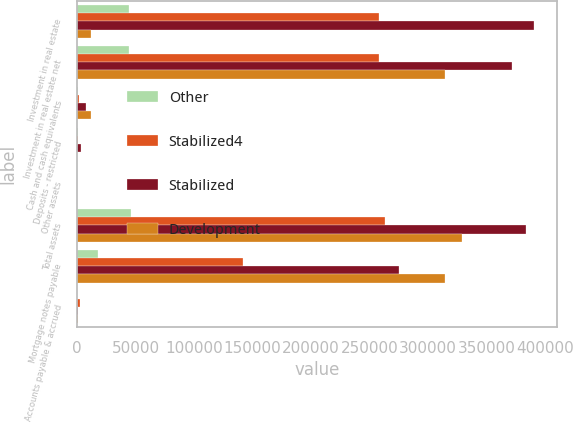Convert chart. <chart><loc_0><loc_0><loc_500><loc_500><stacked_bar_chart><ecel><fcel>Investment in real estate<fcel>Investment in real estate net<fcel>Cash and cash equivalents<fcel>Deposits - restricted<fcel>Other assets<fcel>Total assets<fcel>Mortgage notes payable<fcel>Accounts payable & accrued<nl><fcel>Other<fcel>44006<fcel>44006<fcel>877<fcel>1115<fcel>339<fcel>46337<fcel>18342<fcel>346<nl><fcel>Stabilized4<fcel>257747<fcel>257747<fcel>1288<fcel>922<fcel>268<fcel>263025<fcel>141741<fcel>2215<nl><fcel>Stabilized<fcel>390465<fcel>371994<fcel>7384<fcel>3205<fcel>308<fcel>383525<fcel>275348<fcel>1070<nl><fcel>Development<fcel>11581<fcel>313982<fcel>11581<fcel>8<fcel>143<fcel>328540<fcel>314535<fcel>1259<nl></chart> 